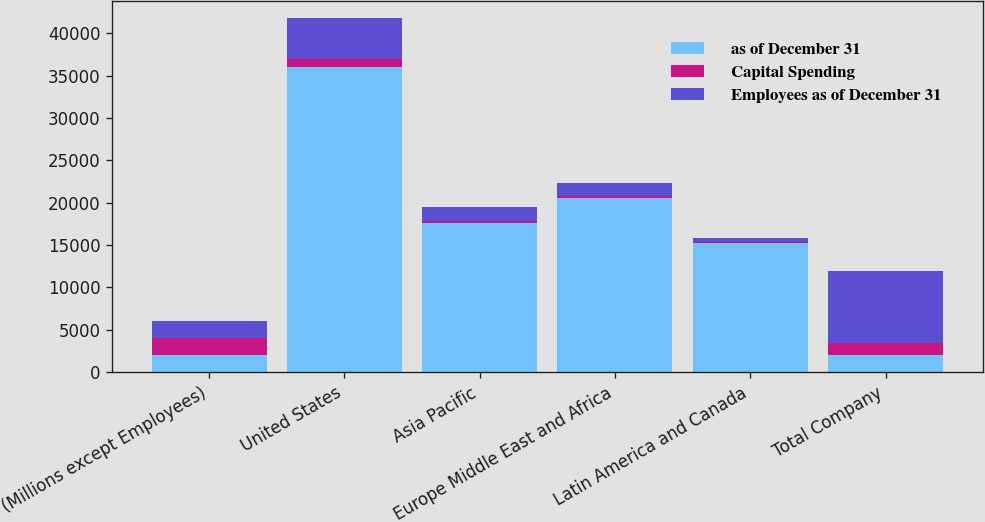Convert chart. <chart><loc_0><loc_0><loc_500><loc_500><stacked_bar_chart><ecel><fcel>(Millions except Employees)<fcel>United States<fcel>Asia Pacific<fcel>Europe Middle East and Africa<fcel>Latin America and Canada<fcel>Total Company<nl><fcel>as of December 31<fcel>2015<fcel>35973<fcel>17642<fcel>20563<fcel>15268<fcel>2015<nl><fcel>Capital Spending<fcel>2015<fcel>936<fcel>172<fcel>249<fcel>104<fcel>1461<nl><fcel>Employees as of December 31<fcel>2015<fcel>4838<fcel>1647<fcel>1531<fcel>499<fcel>8515<nl></chart> 